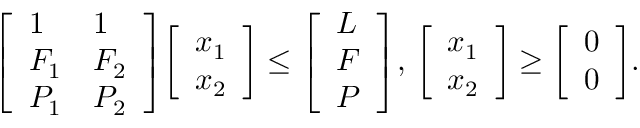<formula> <loc_0><loc_0><loc_500><loc_500>{ \left [ \begin{array} { l l } { 1 } & { 1 } \\ { F _ { 1 } } & { F _ { 2 } } \\ { P _ { 1 } } & { P _ { 2 } } \end{array} \right ] } { \left [ \begin{array} { l } { x _ { 1 } } \\ { x _ { 2 } } \end{array} \right ] } \leq { \left [ \begin{array} { l } { L } \\ { F } \\ { P } \end{array} \right ] } , \, { \left [ \begin{array} { l } { x _ { 1 } } \\ { x _ { 2 } } \end{array} \right ] } \geq { \left [ \begin{array} { l } { 0 } \\ { 0 } \end{array} \right ] } .</formula> 